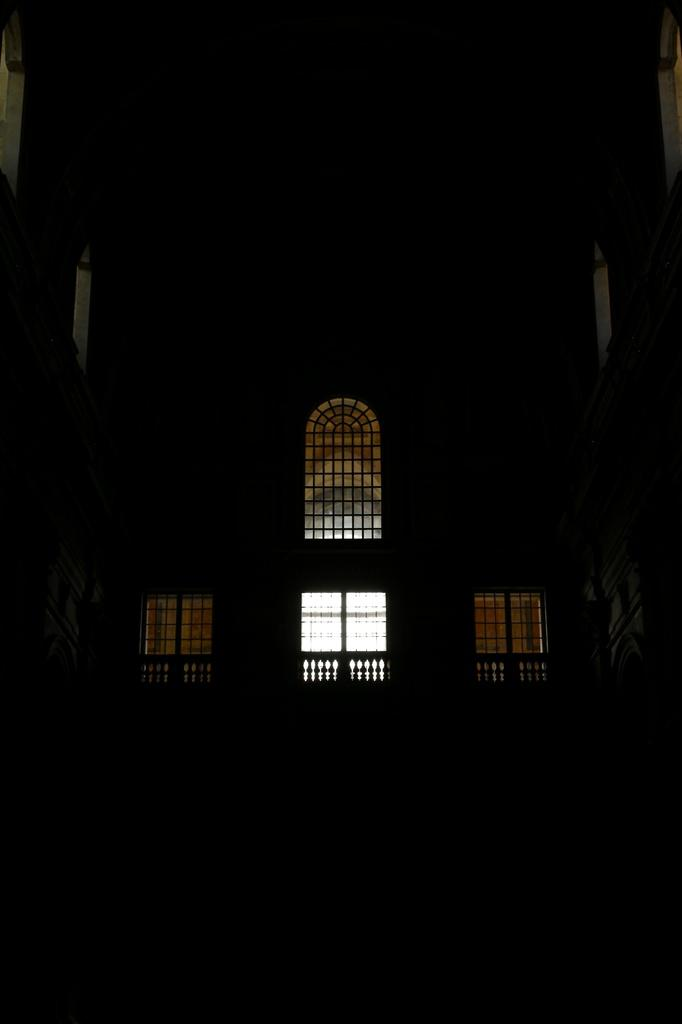What is the overall lighting condition in the image? The image is dark. What architectural features can be seen in the image? There are windows and a fence in the image. Can you see any attempts by the cat to climb the fence in the image? There is no cat present in the image, so it is not possible to see any attempts to climb the fence. 